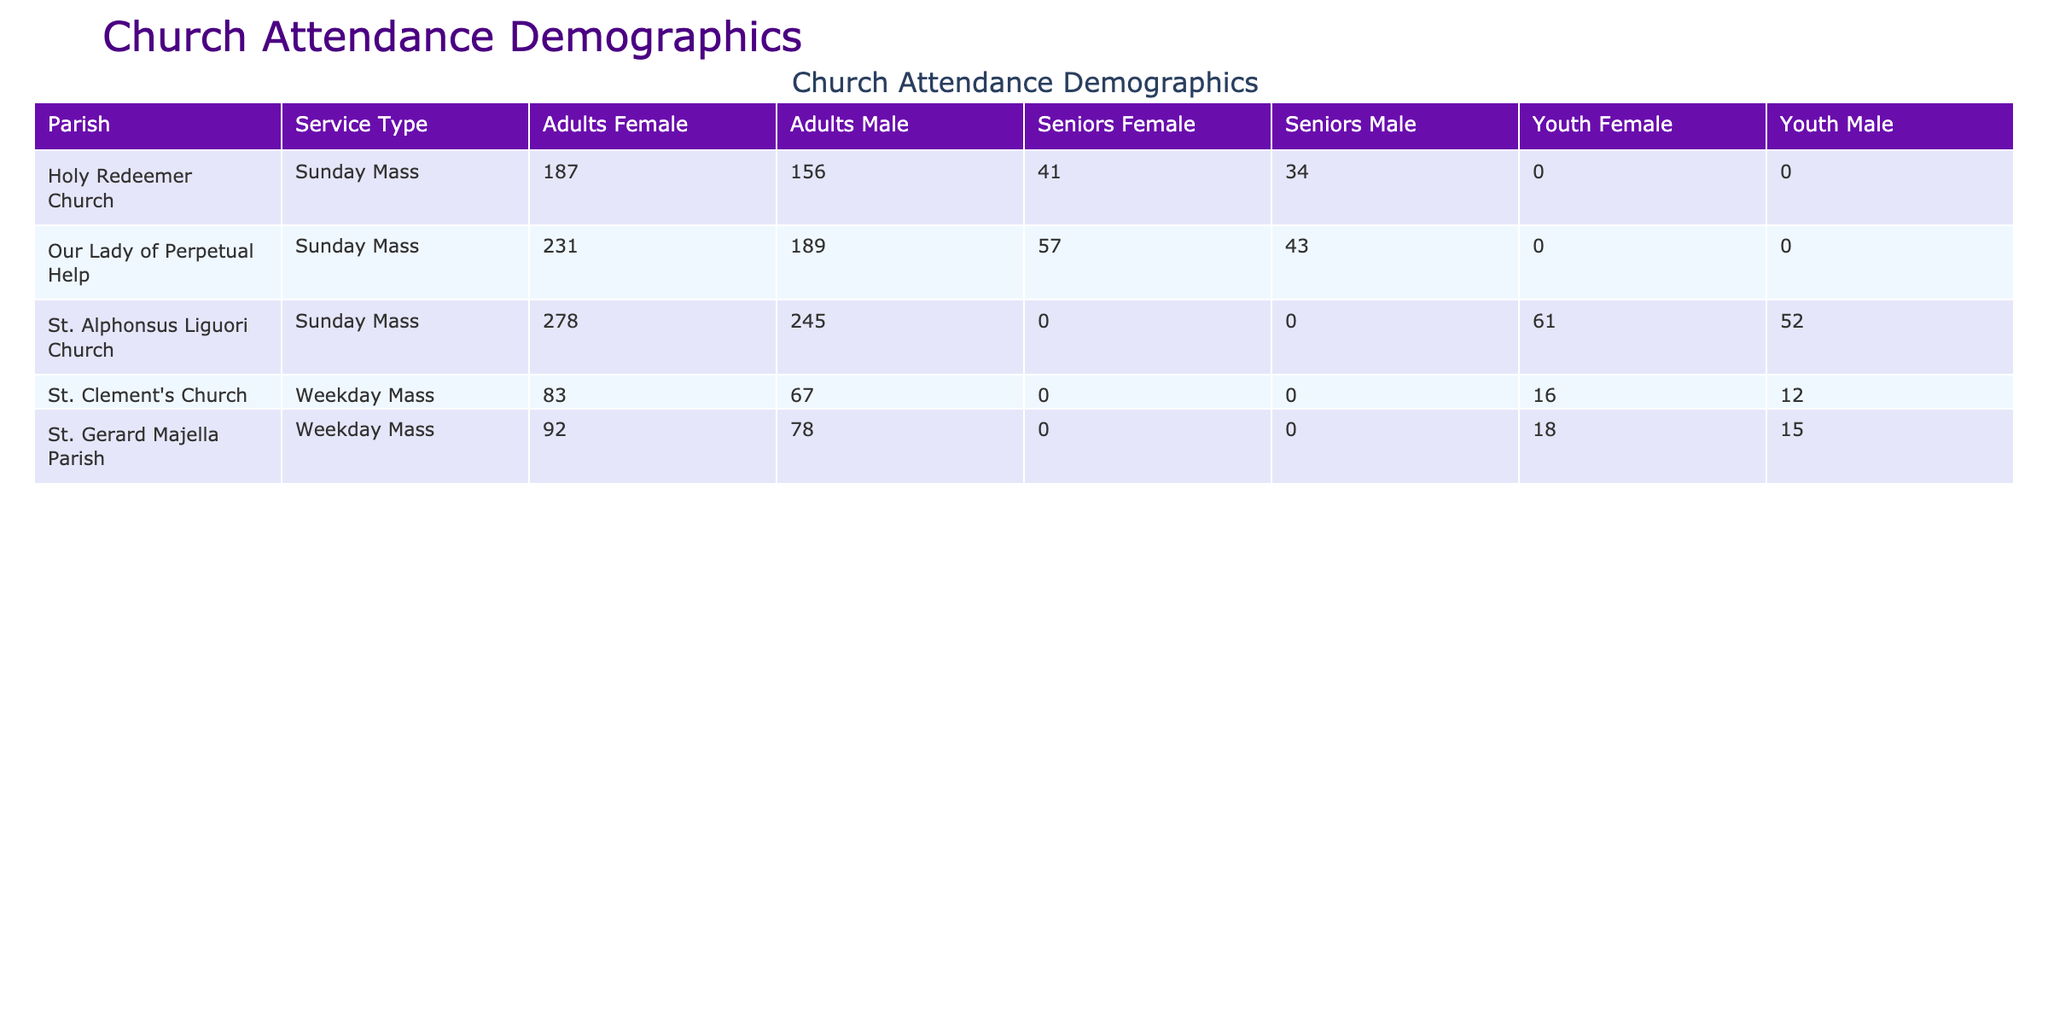What is the total attendance for Sunday Mass at St. Alphonsus Liguori Church? The attendance for Sunday Mass at St. Alphonsus Liguori Church consists of the following numbers: 245 (Male Adults) + 278 (Female Adults) + 52 (Male Youth) + 61 (Female Youth) = 636.
Answer: 636 Which parish had the highest attendance for Weekday Mass? The table shows that St. Gerard Majella Parish has the highest attendance for Weekday Mass with a total of 78 (Male Adults) + 92 (Female Adults) + 15 (Male Youth) + 18 (Female Youth) = 203.
Answer: 203 Are there any Seniors that attended the Sunday Mass at Holy Redeemer Church? Yes, the table indicates an attendance of 34 (Male Seniors) and 41 (Female Seniors) for Holy Redeemer Church during Sunday Mass.
Answer: Yes What is the overall total attendance for all services provided by Our Lady of Perpetual Help? To find the total attendance for Our Lady of Perpetual Help, we sum the attendance from each age group for the Sunday Mass: 189 (Male Adults) + 231 (Female Adults) + 43 (Male Seniors) + 57 (Female Seniors) = 520.
Answer: 520 Which age group had the lowest attendance across all parishes during Weekday Mass? By reviewing the table, for Weekday Mass, the attendance for Youth is lower compared to Adults and Seniors. Specifically, the total for Youth is 15 (Male Youth, St. Gerard Majella) + 18 (Female Youth, St. Gerard Majella) + 12 (Male Youth, St. Clement's) + 16 (Female Youth, St. Clement's) = 61, while Adults have higher numbers.
Answer: Youth What is the average attendance for Sunday Mass across the three parishes listed? To compute the average attendance for Sunday Mass, we first add the attendance for Sunday Mass: 636 (St. Alphonsus) + 420 (Our Lady of Perpetual Help) + 343 (Holy Redeemer) = 1399. There are three parishes, so the average is 1399 / 3 = 466.33.
Answer: 466.33 